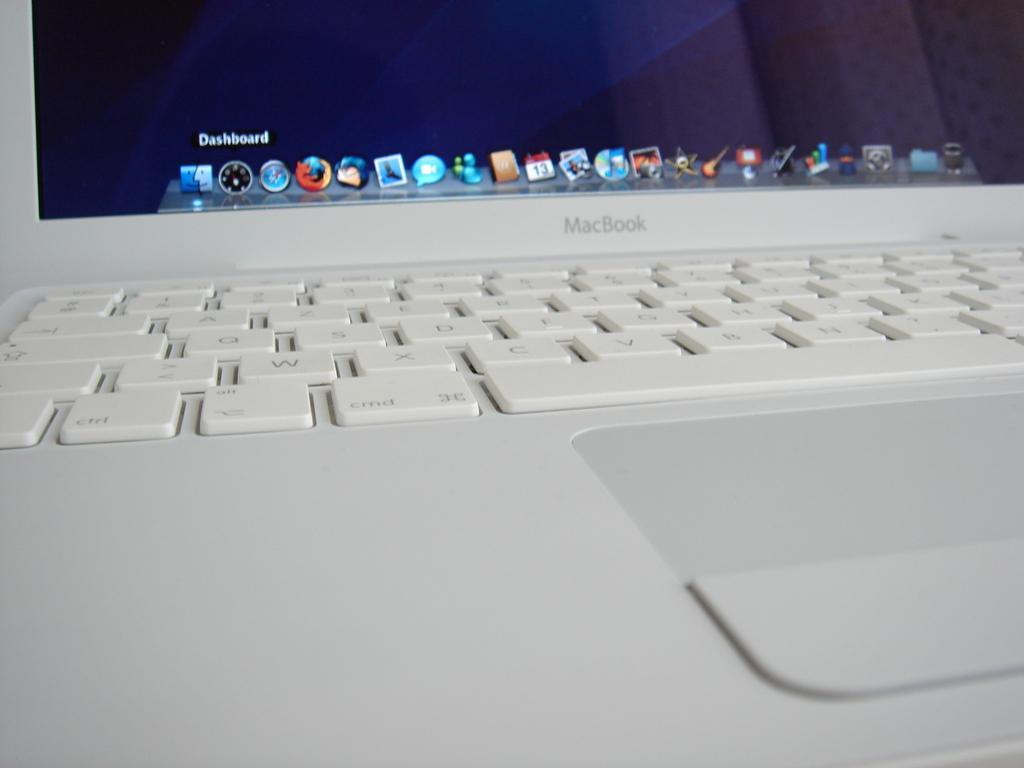Describe this image in one or two sentences. In this picture we can see the partial view of a keyboard & the monitor of a laptop. 